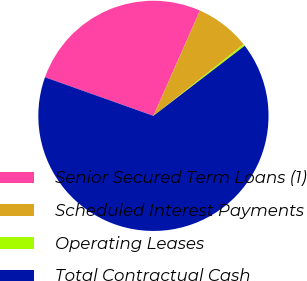Convert chart. <chart><loc_0><loc_0><loc_500><loc_500><pie_chart><fcel>Senior Secured Term Loans (1)<fcel>Scheduled Interest Payments<fcel>Operating Leases<fcel>Total Contractual Cash<nl><fcel>26.18%<fcel>7.7%<fcel>0.26%<fcel>65.87%<nl></chart> 